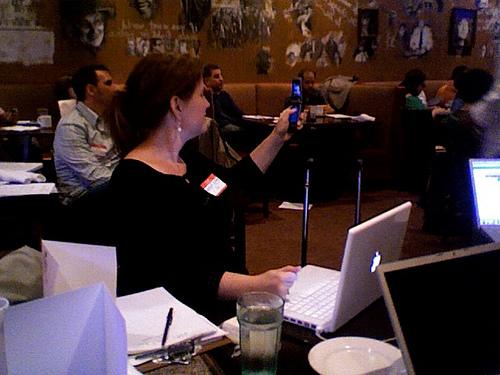How many people are looking away from the camera?
Short answer required. 7. What is the woman doing?
Be succinct. Taking picture. What kind of laptop does the woman have?
Keep it brief. Apple. 